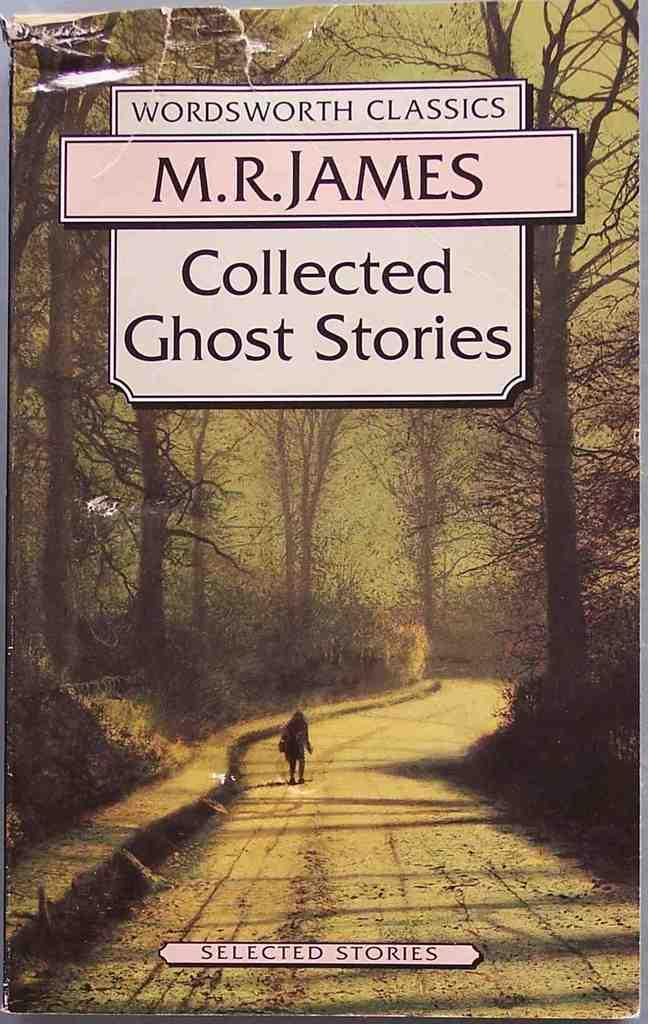<image>
Summarize the visual content of the image. Book cover showing a person walking and the title "Collected Ghost Stories". 